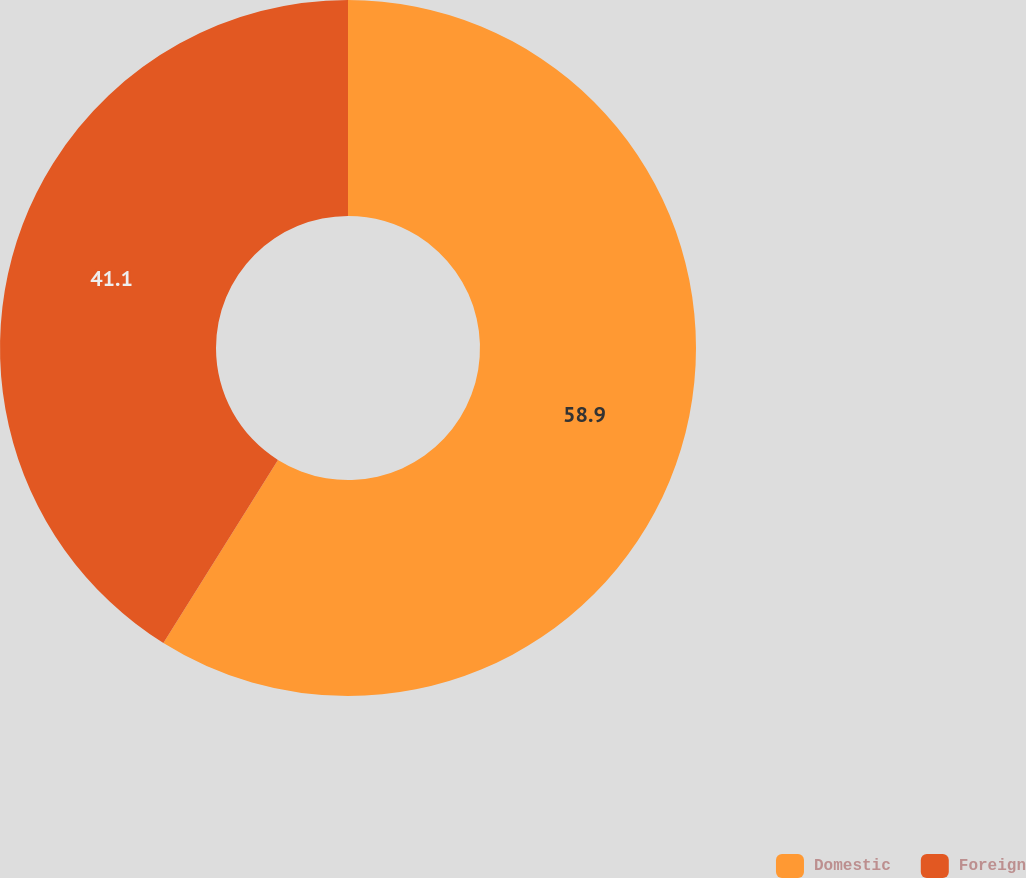Convert chart. <chart><loc_0><loc_0><loc_500><loc_500><pie_chart><fcel>Domestic<fcel>Foreign<nl><fcel>58.9%<fcel>41.1%<nl></chart> 